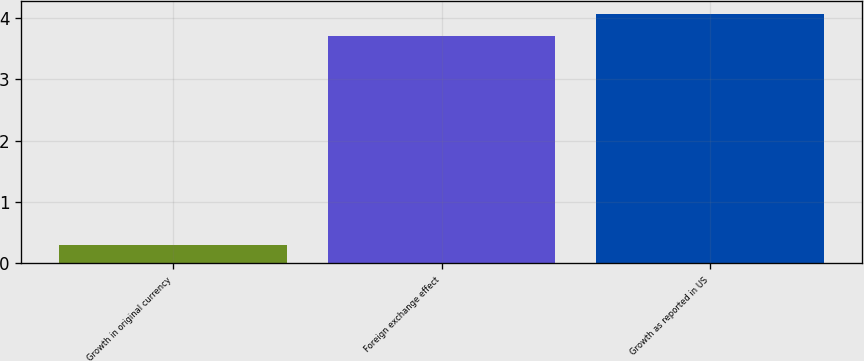Convert chart. <chart><loc_0><loc_0><loc_500><loc_500><bar_chart><fcel>Growth in original currency<fcel>Foreign exchange effect<fcel>Growth as reported in US<nl><fcel>0.3<fcel>3.7<fcel>4.07<nl></chart> 